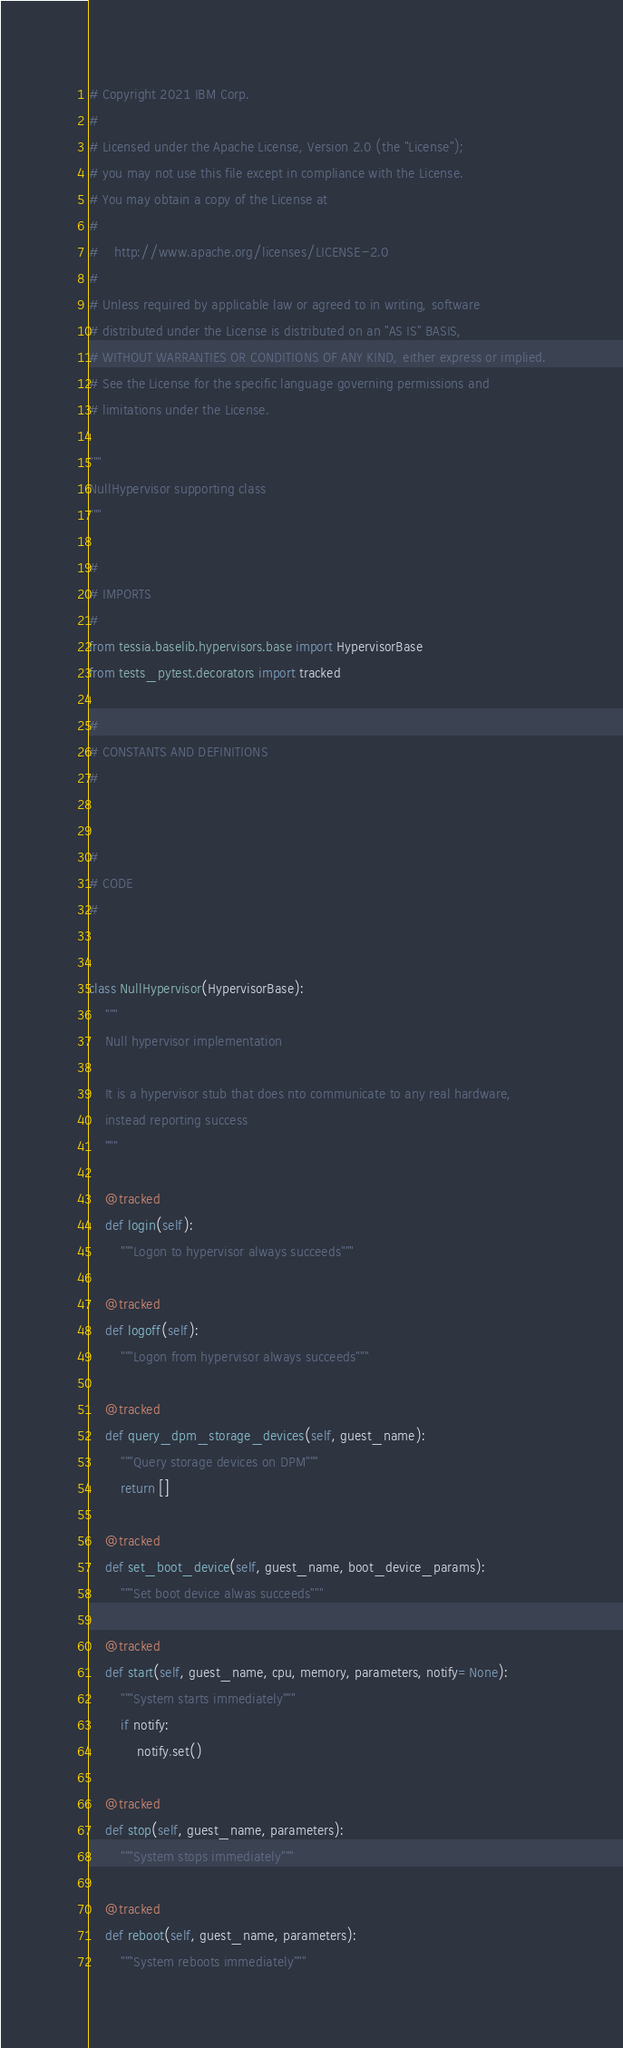<code> <loc_0><loc_0><loc_500><loc_500><_Python_># Copyright 2021 IBM Corp.
#
# Licensed under the Apache License, Version 2.0 (the "License");
# you may not use this file except in compliance with the License.
# You may obtain a copy of the License at
#
#    http://www.apache.org/licenses/LICENSE-2.0
#
# Unless required by applicable law or agreed to in writing, software
# distributed under the License is distributed on an "AS IS" BASIS,
# WITHOUT WARRANTIES OR CONDITIONS OF ANY KIND, either express or implied.
# See the License for the specific language governing permissions and
# limitations under the License.

"""
NullHypervisor supporting class
"""

#
# IMPORTS
#
from tessia.baselib.hypervisors.base import HypervisorBase
from tests_pytest.decorators import tracked

#
# CONSTANTS AND DEFINITIONS
#


#
# CODE
#


class NullHypervisor(HypervisorBase):
    """
    Null hypervisor implementation

    It is a hypervisor stub that does nto communicate to any real hardware,
    instead reporting success
    """

    @tracked
    def login(self):
        """Logon to hypervisor always succeeds"""

    @tracked
    def logoff(self):
        """Logon from hypervisor always succeeds"""

    @tracked
    def query_dpm_storage_devices(self, guest_name):
        """Query storage devices on DPM"""
        return []

    @tracked
    def set_boot_device(self, guest_name, boot_device_params):
        """Set boot device alwas succeeds"""

    @tracked
    def start(self, guest_name, cpu, memory, parameters, notify=None):
        """System starts immediately"""
        if notify:
            notify.set()

    @tracked
    def stop(self, guest_name, parameters):
        """System stops immediately"""

    @tracked
    def reboot(self, guest_name, parameters):
        """System reboots immediately"""
</code> 